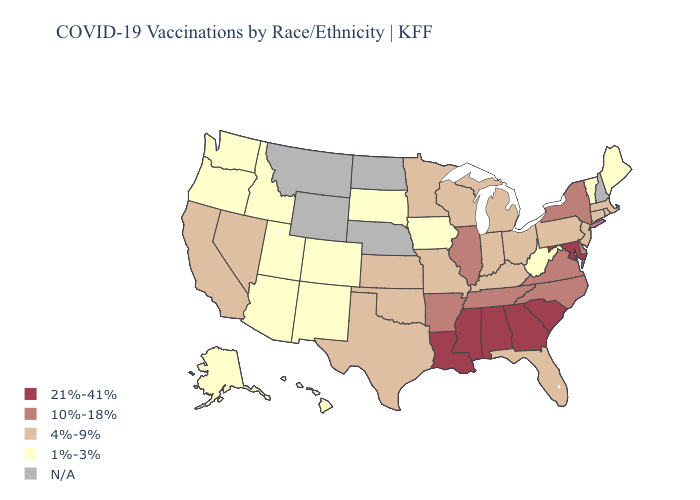Name the states that have a value in the range N/A?
Quick response, please. Montana, Nebraska, New Hampshire, North Dakota, Wyoming. What is the lowest value in states that border Oklahoma?
Be succinct. 1%-3%. Which states have the lowest value in the MidWest?
Write a very short answer. Iowa, South Dakota. Name the states that have a value in the range 10%-18%?
Keep it brief. Arkansas, Delaware, Illinois, New York, North Carolina, Tennessee, Virginia. Does the map have missing data?
Keep it brief. Yes. What is the value of Illinois?
Quick response, please. 10%-18%. Name the states that have a value in the range 1%-3%?
Be succinct. Alaska, Arizona, Colorado, Hawaii, Idaho, Iowa, Maine, New Mexico, Oregon, South Dakota, Utah, Vermont, Washington, West Virginia. Among the states that border Wyoming , which have the lowest value?
Quick response, please. Colorado, Idaho, South Dakota, Utah. What is the value of Rhode Island?
Write a very short answer. 4%-9%. How many symbols are there in the legend?
Short answer required. 5. What is the value of New York?
Give a very brief answer. 10%-18%. Among the states that border Georgia , does South Carolina have the highest value?
Be succinct. Yes. What is the value of Kentucky?
Give a very brief answer. 4%-9%. What is the value of Nevada?
Concise answer only. 4%-9%. 